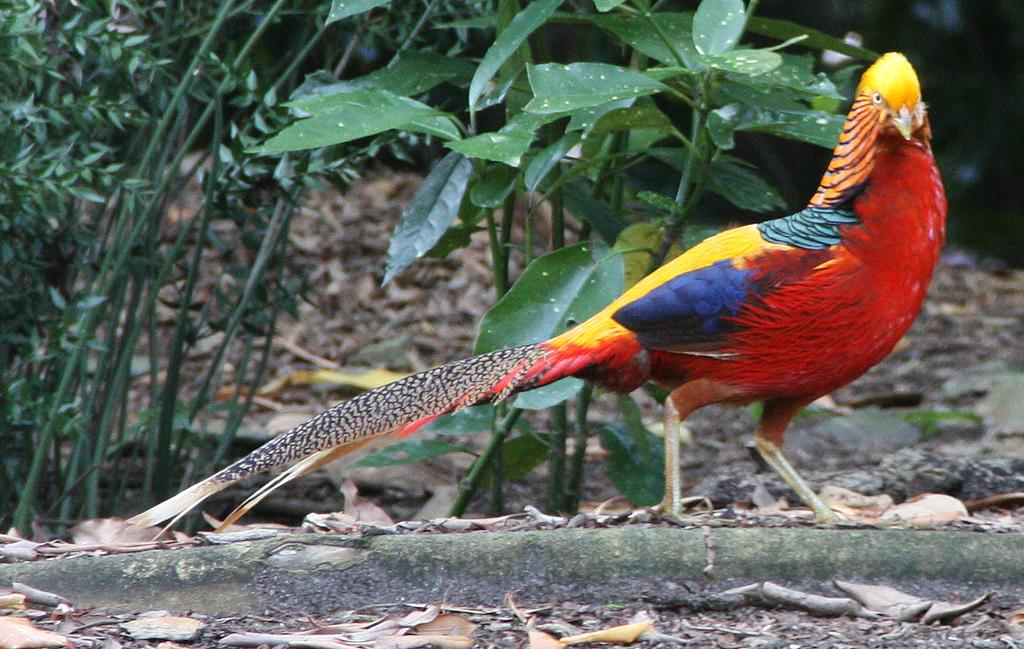What type of animal can be seen in the image? There is a colorful bird in the image. What can be seen in the background of the image? There are green leaves and stems in the background of the image. What is present on the ground in the image? Dried leaves are visible on the ground in the image. Can you tell me how many bells are hanging from the bird's neck in the image? There are no bells present in the image; the bird is not wearing any accessories. 